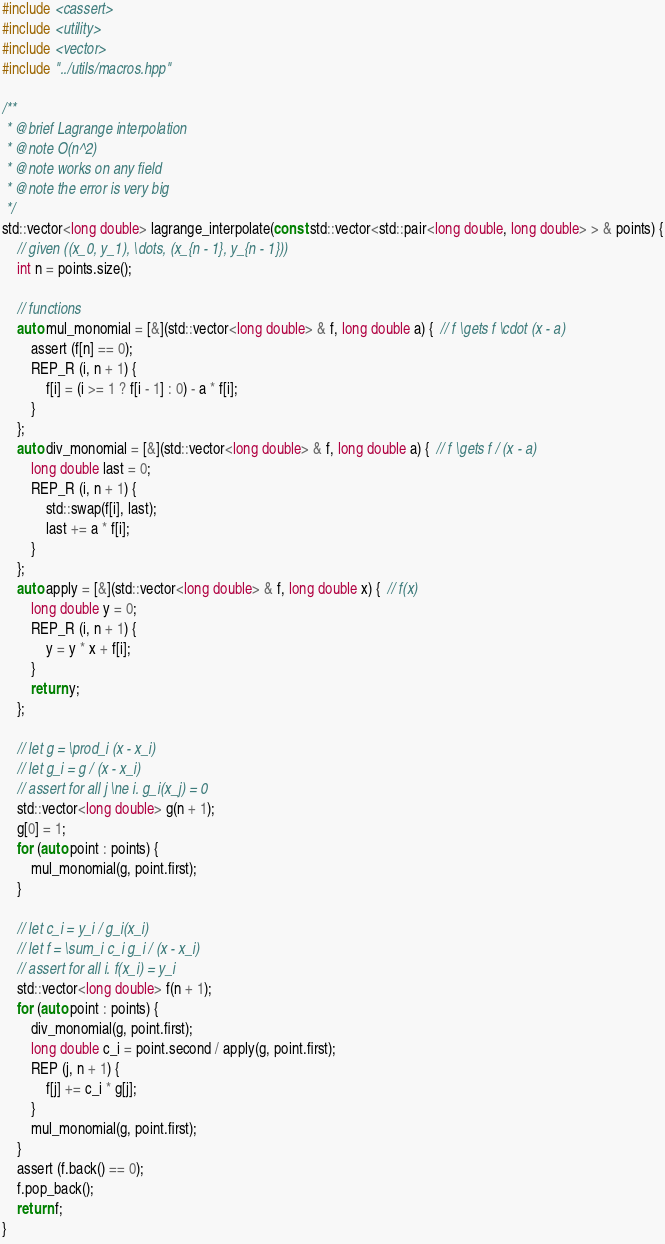Convert code to text. <code><loc_0><loc_0><loc_500><loc_500><_C++_>#include <cassert>
#include <utility>
#include <vector>
#include "../utils/macros.hpp"

/**
 * @brief Lagrange interpolation
 * @note O(n^2)
 * @note works on any field
 * @note the error is very big
 */
std::vector<long double> lagrange_interpolate(const std::vector<std::pair<long double, long double> > & points) {
    // given ((x_0, y_1), \dots, (x_{n - 1}, y_{n - 1}))
    int n = points.size();

    // functions
    auto mul_monomial = [&](std::vector<long double> & f, long double a) {  // f \gets f \cdot (x - a)
        assert (f[n] == 0);
        REP_R (i, n + 1) {
            f[i] = (i >= 1 ? f[i - 1] : 0) - a * f[i];
        }
    };
    auto div_monomial = [&](std::vector<long double> & f, long double a) {  // f \gets f / (x - a)
        long double last = 0;
        REP_R (i, n + 1) {
            std::swap(f[i], last);
            last += a * f[i];
        }
    };
    auto apply = [&](std::vector<long double> & f, long double x) {  // f(x)
        long double y = 0;
        REP_R (i, n + 1) {
            y = y * x + f[i];
        }
        return y;
    };

    // let g = \prod_i (x - x_i)
    // let g_i = g / (x - x_i)
    // assert for all j \ne i. g_i(x_j) = 0
    std::vector<long double> g(n + 1);
    g[0] = 1;
    for (auto point : points) {
        mul_monomial(g, point.first);
    }

    // let c_i = y_i / g_i(x_i)
    // let f = \sum_i c_i g_i / (x - x_i)
    // assert for all i. f(x_i) = y_i
    std::vector<long double> f(n + 1);
    for (auto point : points) {
        div_monomial(g, point.first);
        long double c_i = point.second / apply(g, point.first);
        REP (j, n + 1) {
            f[j] += c_i * g[j];
        }
        mul_monomial(g, point.first);
    }
    assert (f.back() == 0);
    f.pop_back();
    return f;
}
</code> 